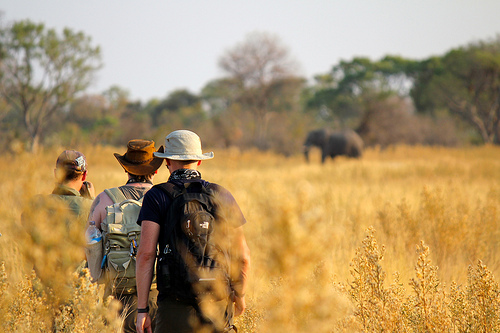Does the man hat look white? No, the man's hat does not look white. 